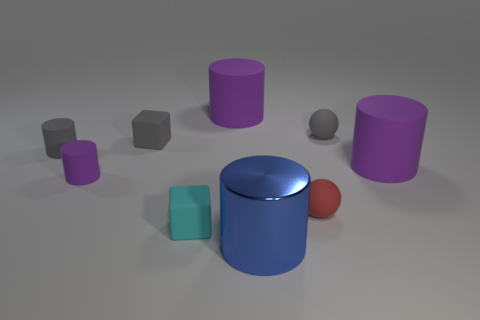What shape is the tiny cyan thing that is made of the same material as the tiny gray cube?
Provide a succinct answer. Cube. Are there any other things that have the same shape as the tiny red rubber object?
Your answer should be very brief. Yes. What number of tiny matte blocks are on the left side of the small cyan thing?
Provide a short and direct response. 1. Are there any large brown cylinders?
Your response must be concise. No. What is the color of the large matte thing behind the cylinder that is on the right side of the cylinder in front of the red rubber ball?
Your answer should be compact. Purple. There is a purple matte thing on the right side of the blue object; is there a purple rubber thing to the left of it?
Provide a succinct answer. Yes. Do the cube in front of the small purple cylinder and the large rubber cylinder right of the big blue metallic cylinder have the same color?
Ensure brevity in your answer.  No. How many other cylinders have the same size as the metallic cylinder?
Provide a succinct answer. 2. There is a purple thing on the right side of the metal thing; is it the same size as the gray cube?
Offer a terse response. No. The red thing has what shape?
Make the answer very short. Sphere. 